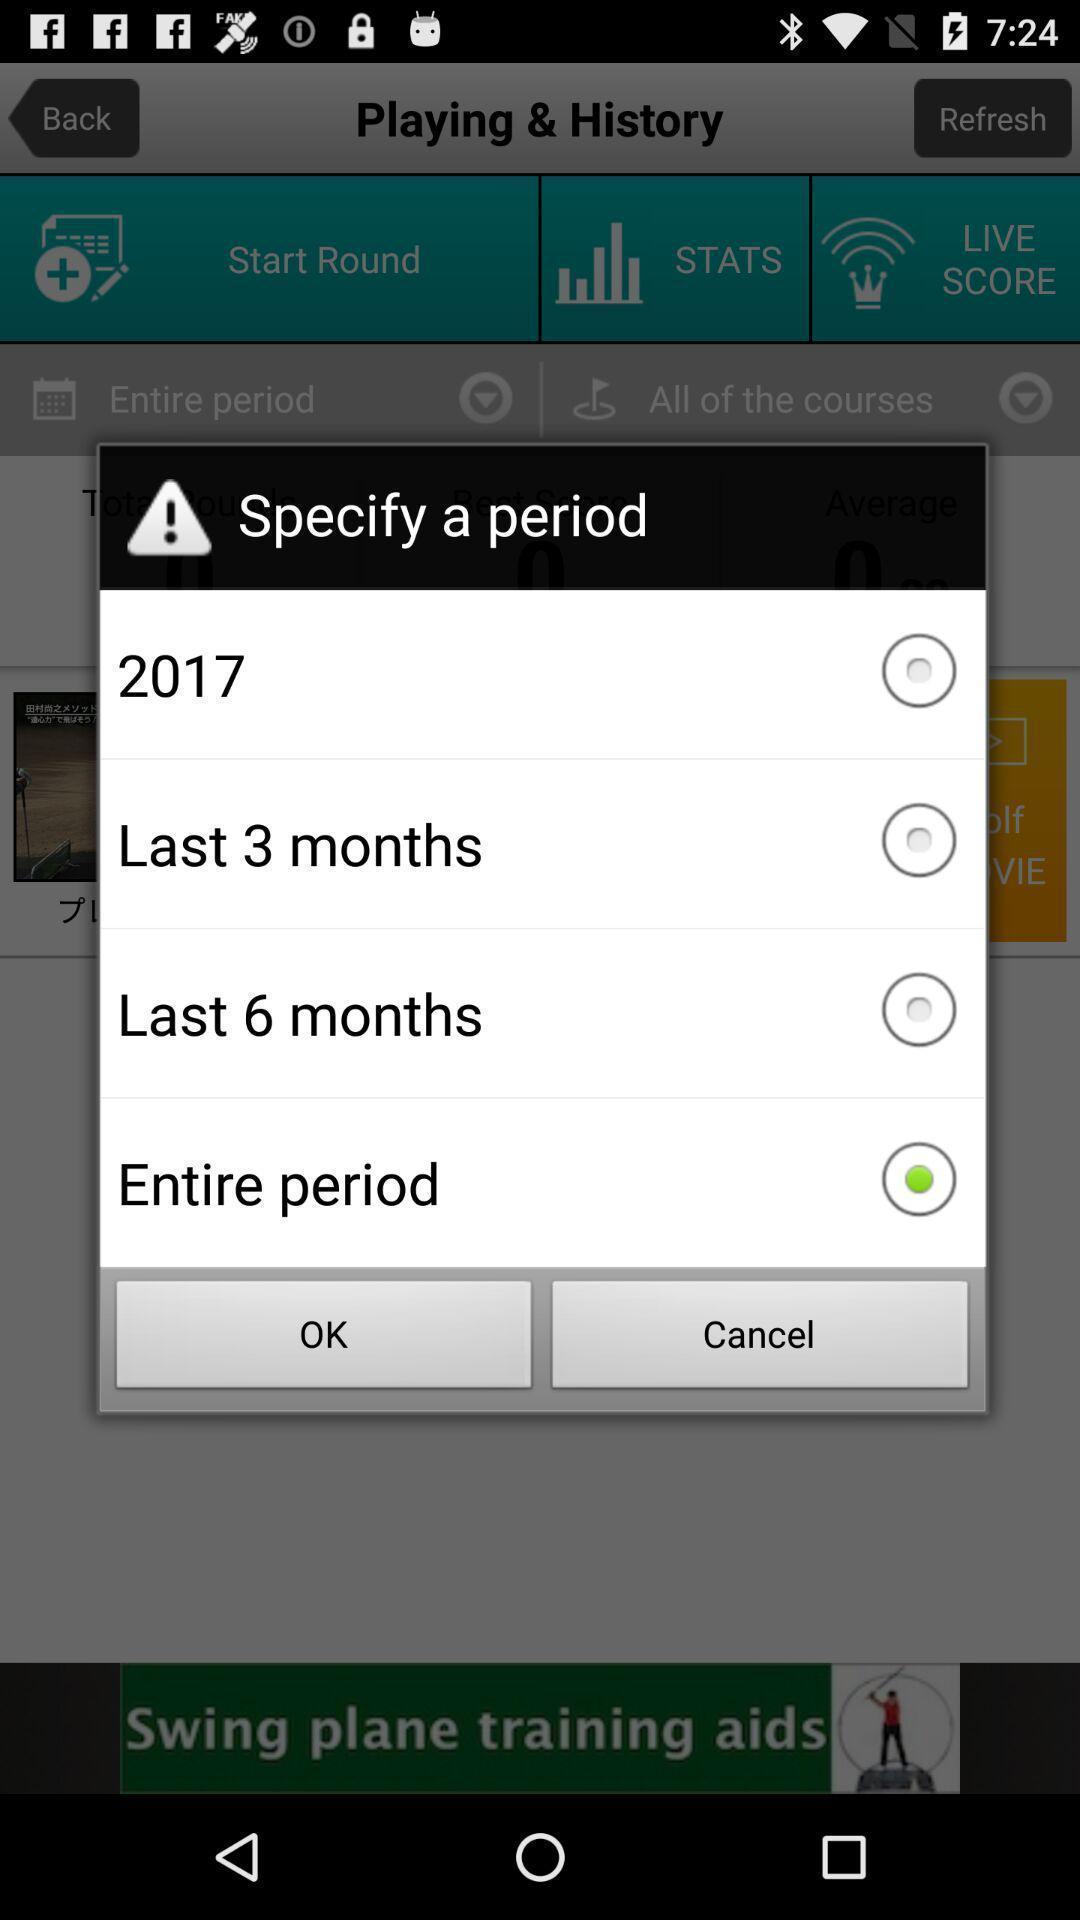Tell me what you see in this picture. Pop-up to select a time period. 